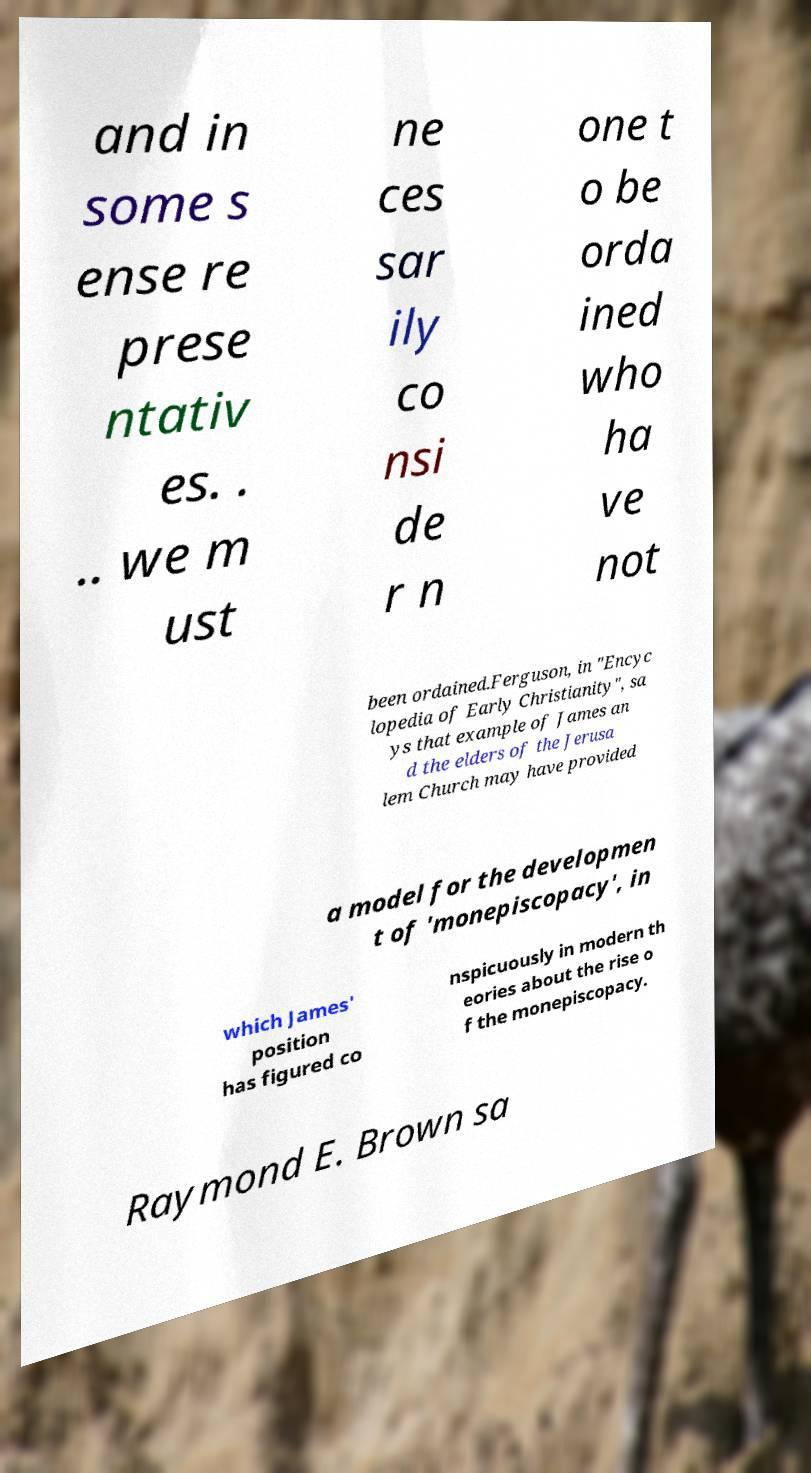For documentation purposes, I need the text within this image transcribed. Could you provide that? and in some s ense re prese ntativ es. . .. we m ust ne ces sar ily co nsi de r n one t o be orda ined who ha ve not been ordained.Ferguson, in "Encyc lopedia of Early Christianity", sa ys that example of James an d the elders of the Jerusa lem Church may have provided a model for the developmen t of 'monepiscopacy', in which James' position has figured co nspicuously in modern th eories about the rise o f the monepiscopacy. Raymond E. Brown sa 